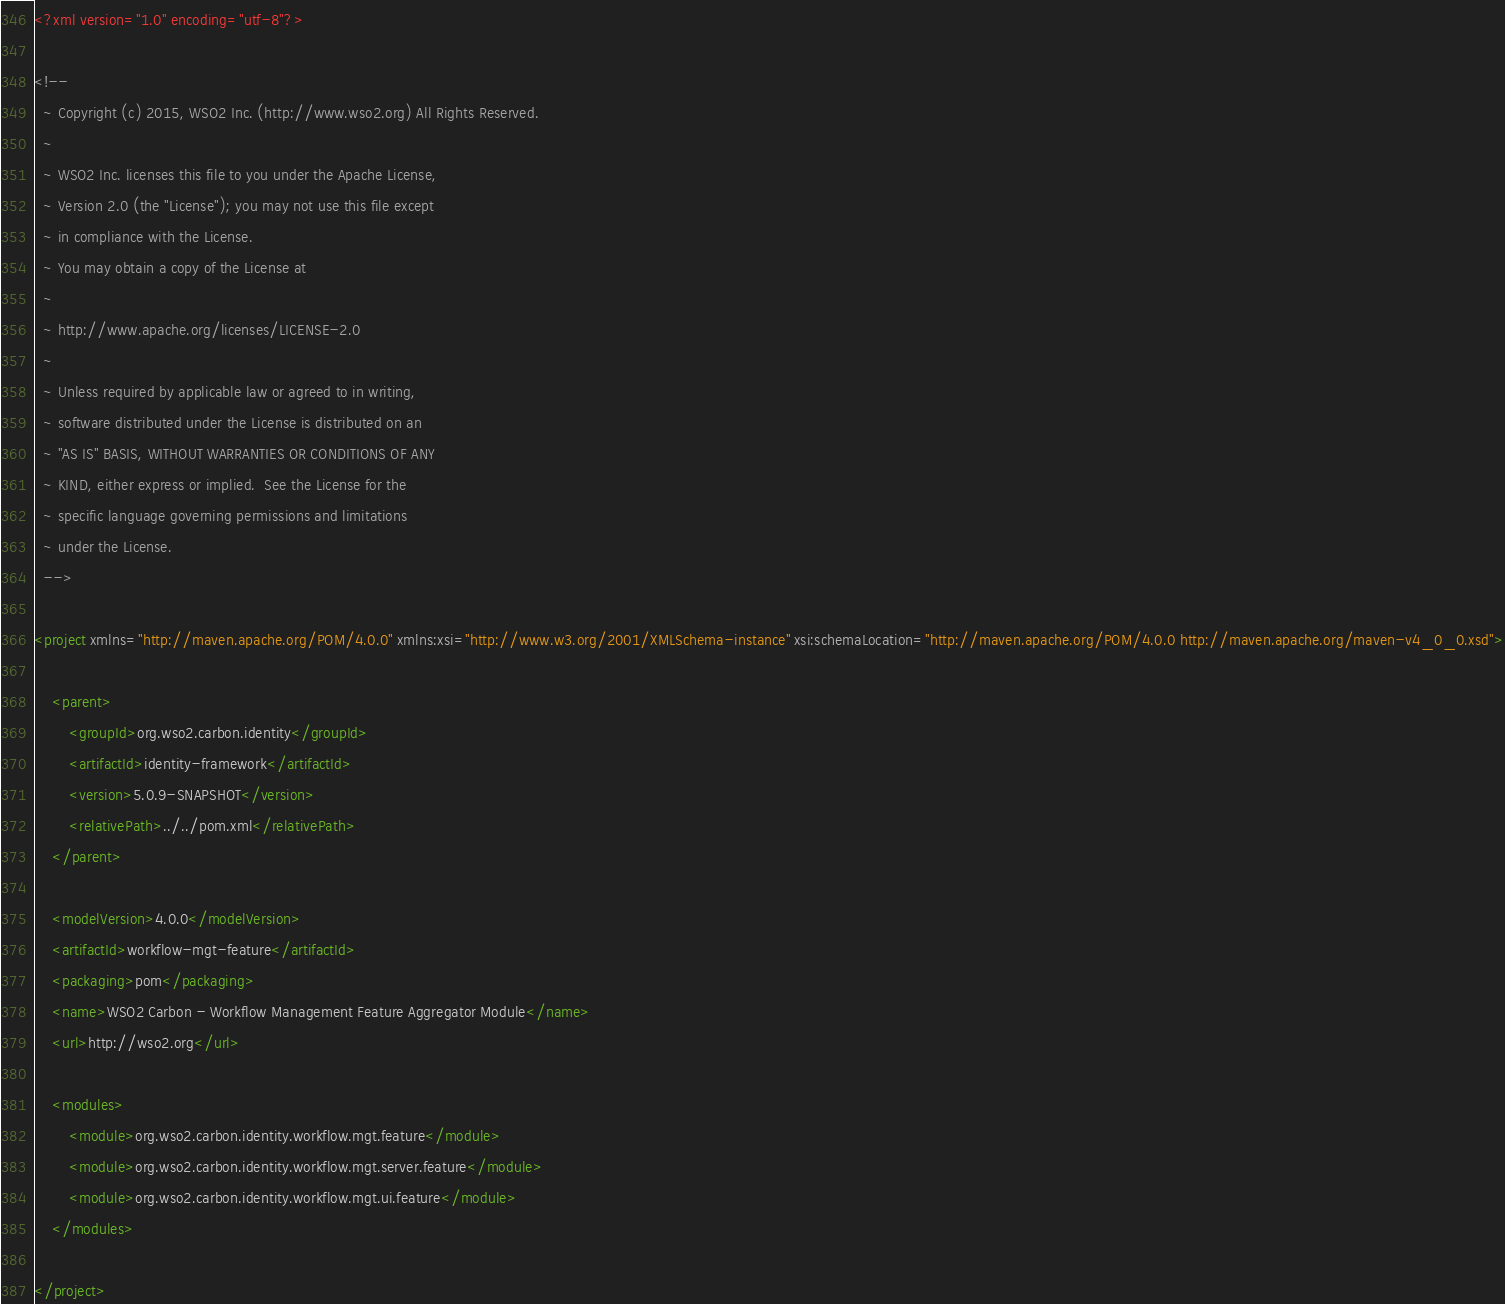<code> <loc_0><loc_0><loc_500><loc_500><_XML_><?xml version="1.0" encoding="utf-8"?>

<!--
  ~ Copyright (c) 2015, WSO2 Inc. (http://www.wso2.org) All Rights Reserved.
  ~
  ~ WSO2 Inc. licenses this file to you under the Apache License,
  ~ Version 2.0 (the "License"); you may not use this file except
  ~ in compliance with the License.
  ~ You may obtain a copy of the License at
  ~
  ~ http://www.apache.org/licenses/LICENSE-2.0
  ~
  ~ Unless required by applicable law or agreed to in writing,
  ~ software distributed under the License is distributed on an
  ~ "AS IS" BASIS, WITHOUT WARRANTIES OR CONDITIONS OF ANY
  ~ KIND, either express or implied.  See the License for the
  ~ specific language governing permissions and limitations
  ~ under the License.
  -->

<project xmlns="http://maven.apache.org/POM/4.0.0" xmlns:xsi="http://www.w3.org/2001/XMLSchema-instance" xsi:schemaLocation="http://maven.apache.org/POM/4.0.0 http://maven.apache.org/maven-v4_0_0.xsd">

    <parent>
        <groupId>org.wso2.carbon.identity</groupId>
        <artifactId>identity-framework</artifactId>
        <version>5.0.9-SNAPSHOT</version>
        <relativePath>../../pom.xml</relativePath>
    </parent>

    <modelVersion>4.0.0</modelVersion>
    <artifactId>workflow-mgt-feature</artifactId>
    <packaging>pom</packaging>
    <name>WSO2 Carbon - Workflow Management Feature Aggregator Module</name>
    <url>http://wso2.org</url>

    <modules>
        <module>org.wso2.carbon.identity.workflow.mgt.feature</module>
        <module>org.wso2.carbon.identity.workflow.mgt.server.feature</module>
        <module>org.wso2.carbon.identity.workflow.mgt.ui.feature</module>
    </modules>

</project>

</code> 